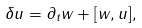Convert formula to latex. <formula><loc_0><loc_0><loc_500><loc_500>\delta u = \partial _ { t } w + [ w , u ] ,</formula> 